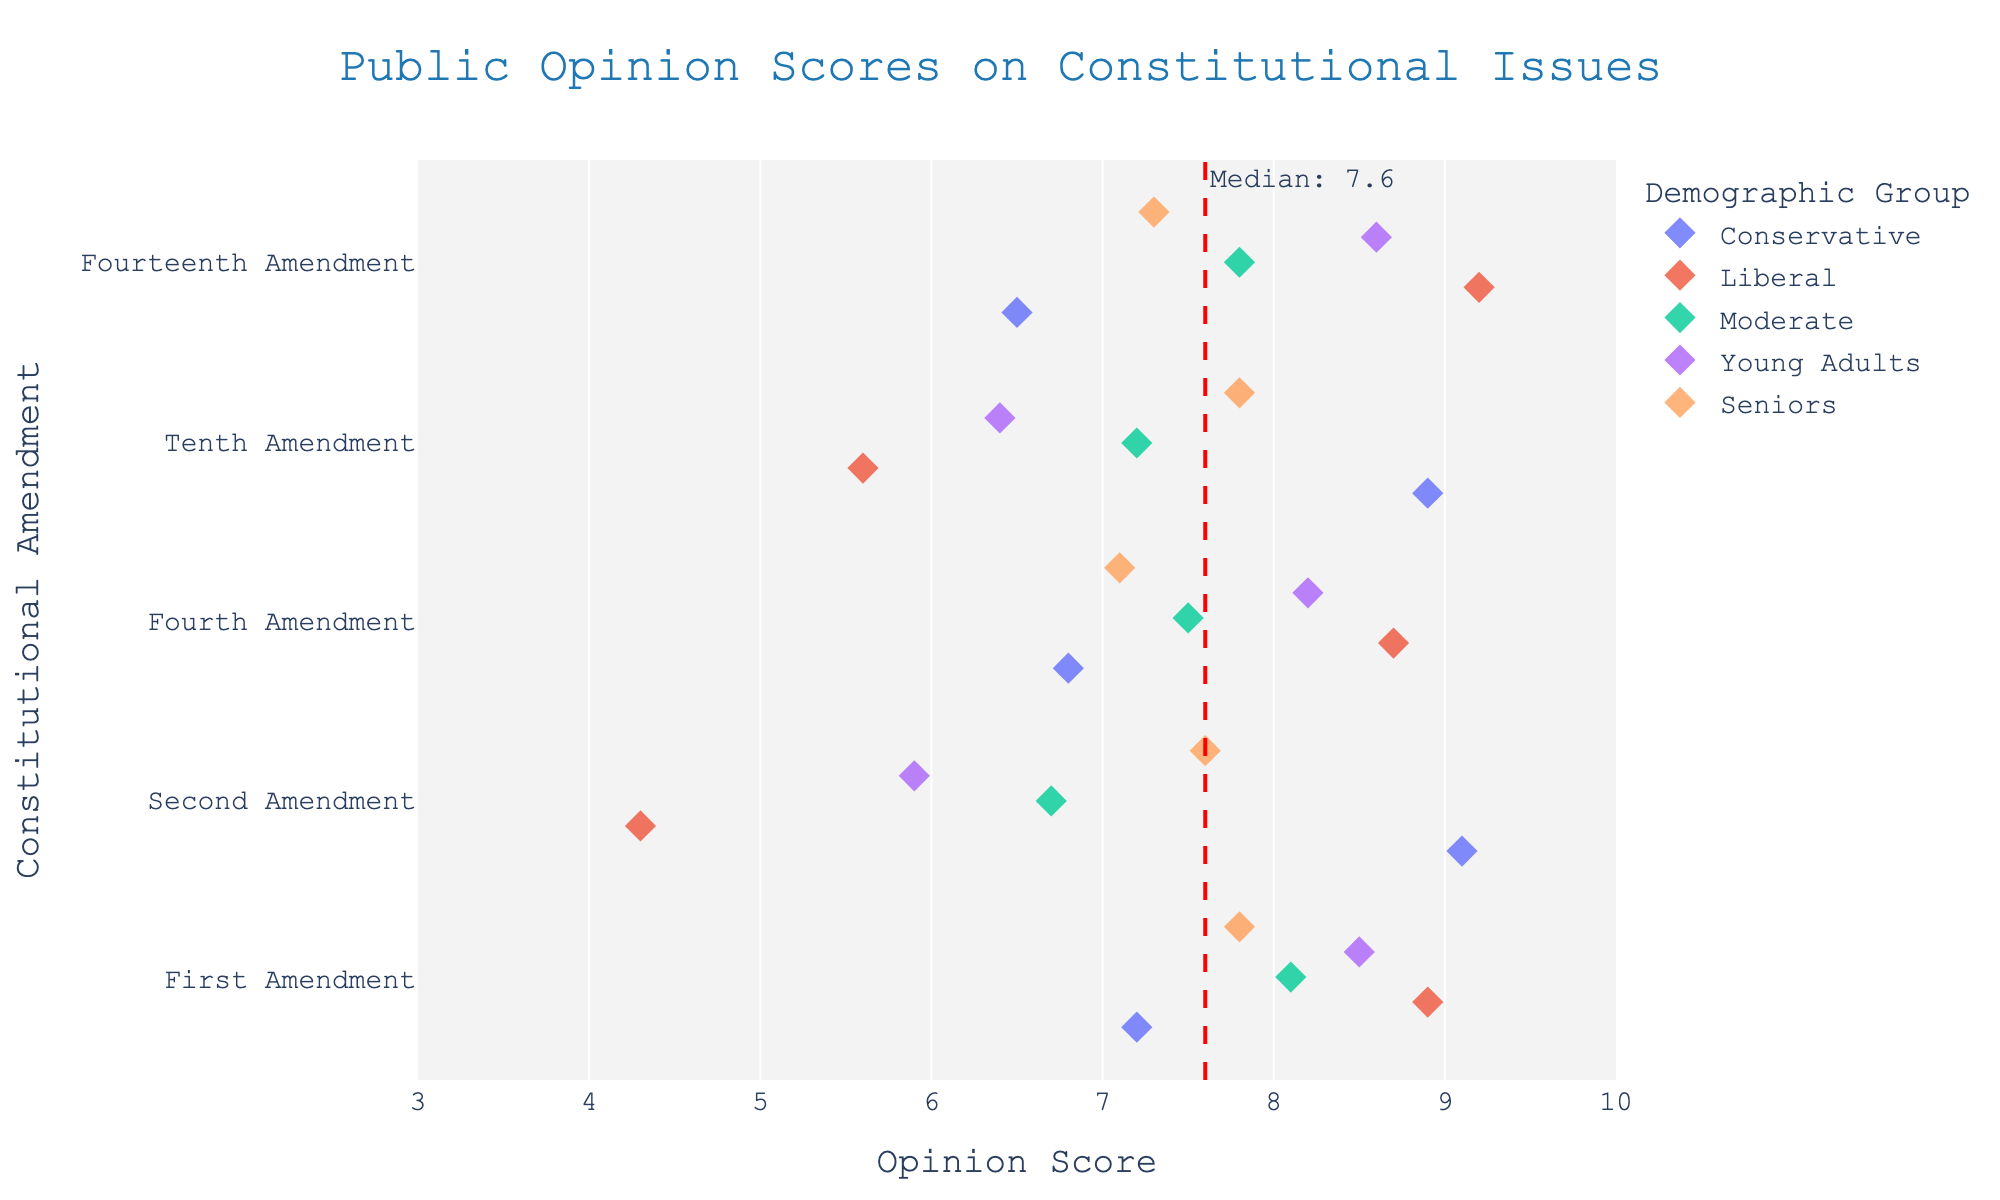What's the title of the plot? The title is usually located at the top of the plot and describes the main theme. In this figure, it is visible at the top center.
Answer: Public Opinion Scores on Constitutional Issues What is the color used for the 'Conservative' demographic group? In strip plots, different demographic groups are often represented by different colors. By looking at the legend, one can identify the color.
Answer: Specified color for 'Conservative' Which Amendment has the highest opinion score among 'Liberals'? To find the highest opinion score, look at the different scores for 'Liberals' across all Amendments and identify the highest value. The Fourth Amendment shows a score of 9.2.
Answer: Fourteenth Amendment What's the median opinion score across all data points? A red dashed line with an annotation "Median: 7.7" indicates the median value for all the data points in the plot. This helps in understanding the distribution of scores.
Answer: 7.7 Which demographic group shows the most agreement (consistently close scores) across all Amendments? Consistent scores imply less variation. By looking at the spread of scores for each demographic group across different Amendments, 'Seniors' show less variation in their scores.
Answer: Seniors What is the opinion score range for 'Young Adults' on the First Amendment? Look along the First Amendment row for the 'Young Adults' color marker and find the score, which is 8.5.
Answer: 8.5 Compare the opinion scores of 'Moderate' on the Second and Fourth Amendments. Identify the markers for 'Moderates' on both the Second Amendment (6.7) and Fourth Amendment (7.5). Compare the values.
Answer: Second Amendment: 6.7, Fourth Amendment: 7.5 Which Amendment has the lowest opinion score among all demographics? Look for the lowest score across all data points in the plot. The lowest score is 4.3 in the Second Amendment by 'Liberals'.
Answer: Second Amendment by Liberals Are there any Amendments where all demographic groups have an opinion score above the median? Verify if for any Amendment, each demographic group has an opinion score higher than 7.7. No such Amendment is found as several scores are below the median.
Answer: No How do the opinion scores for the Second Amendment compare between 'Conservatives' and 'Liberals'? Find and compare the scores for 'Conservatives' (9.1) and 'Liberals' (4.3) on the Second Amendment, noting the significant difference between the two.
Answer: Conservatives: 9.1, Liberals: 4.3 